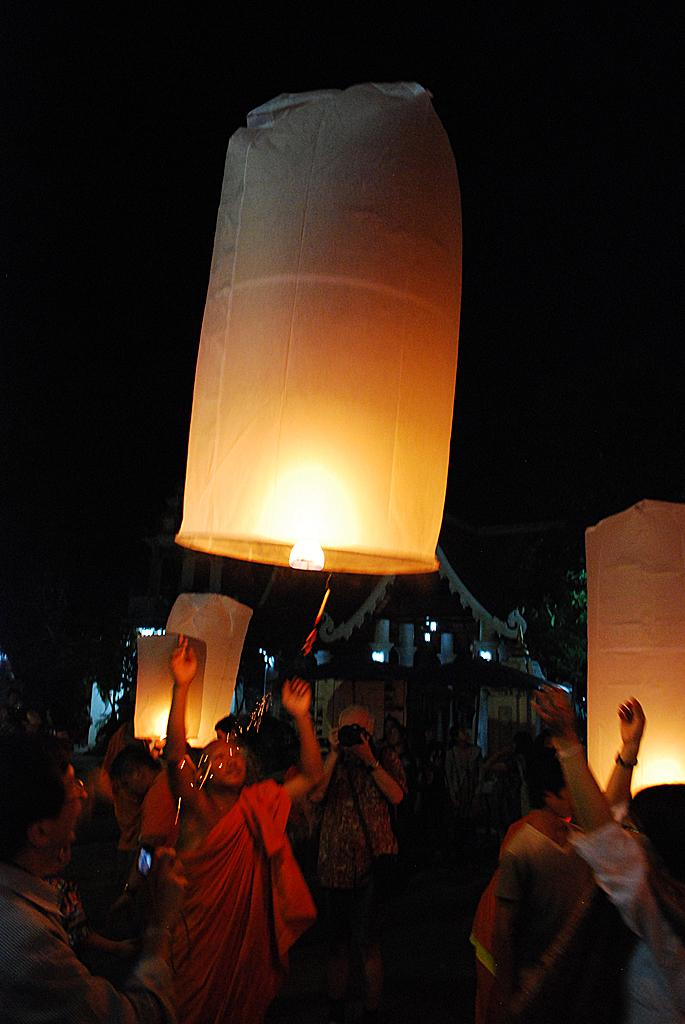What activity are the people in the image engaged in? The people in the image are flying sky lanterns. Can you describe what one person is doing in the image? One person is holding a camera and taking pictures. What can be seen in the background of the image? There are buildings and trees visible in the background. What type of shoe is the baby wearing in the image? There is no baby or shoe present in the image. What is the frame of the image made of? The frame of the image is not visible in the image itself, as it is a photograph or digital representation. 